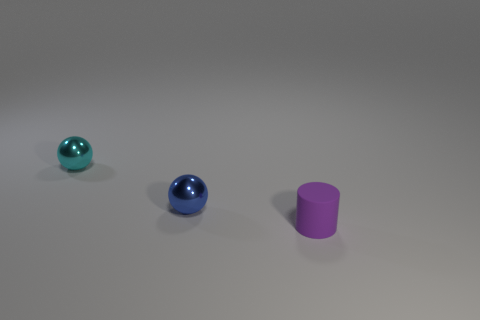Is there a tiny blue cylinder made of the same material as the small blue sphere?
Make the answer very short. No. What number of small things are both in front of the cyan ball and behind the small purple cylinder?
Your answer should be compact. 1. There is a tiny thing that is to the right of the tiny blue shiny ball; what material is it?
Keep it short and to the point. Rubber. There is a blue object that is the same material as the cyan thing; what size is it?
Give a very brief answer. Small. There is a small purple cylinder; are there any small cylinders behind it?
Your answer should be compact. No. What is the size of the cyan shiny thing that is the same shape as the small blue object?
Your answer should be compact. Small. There is a rubber cylinder; is its color the same as the metallic ball left of the blue object?
Provide a short and direct response. No. Are there fewer spheres than large metal blocks?
Provide a succinct answer. No. What number of large gray rubber spheres are there?
Offer a terse response. 0. Is the number of spheres right of the small blue metal ball less than the number of cylinders?
Keep it short and to the point. Yes. 